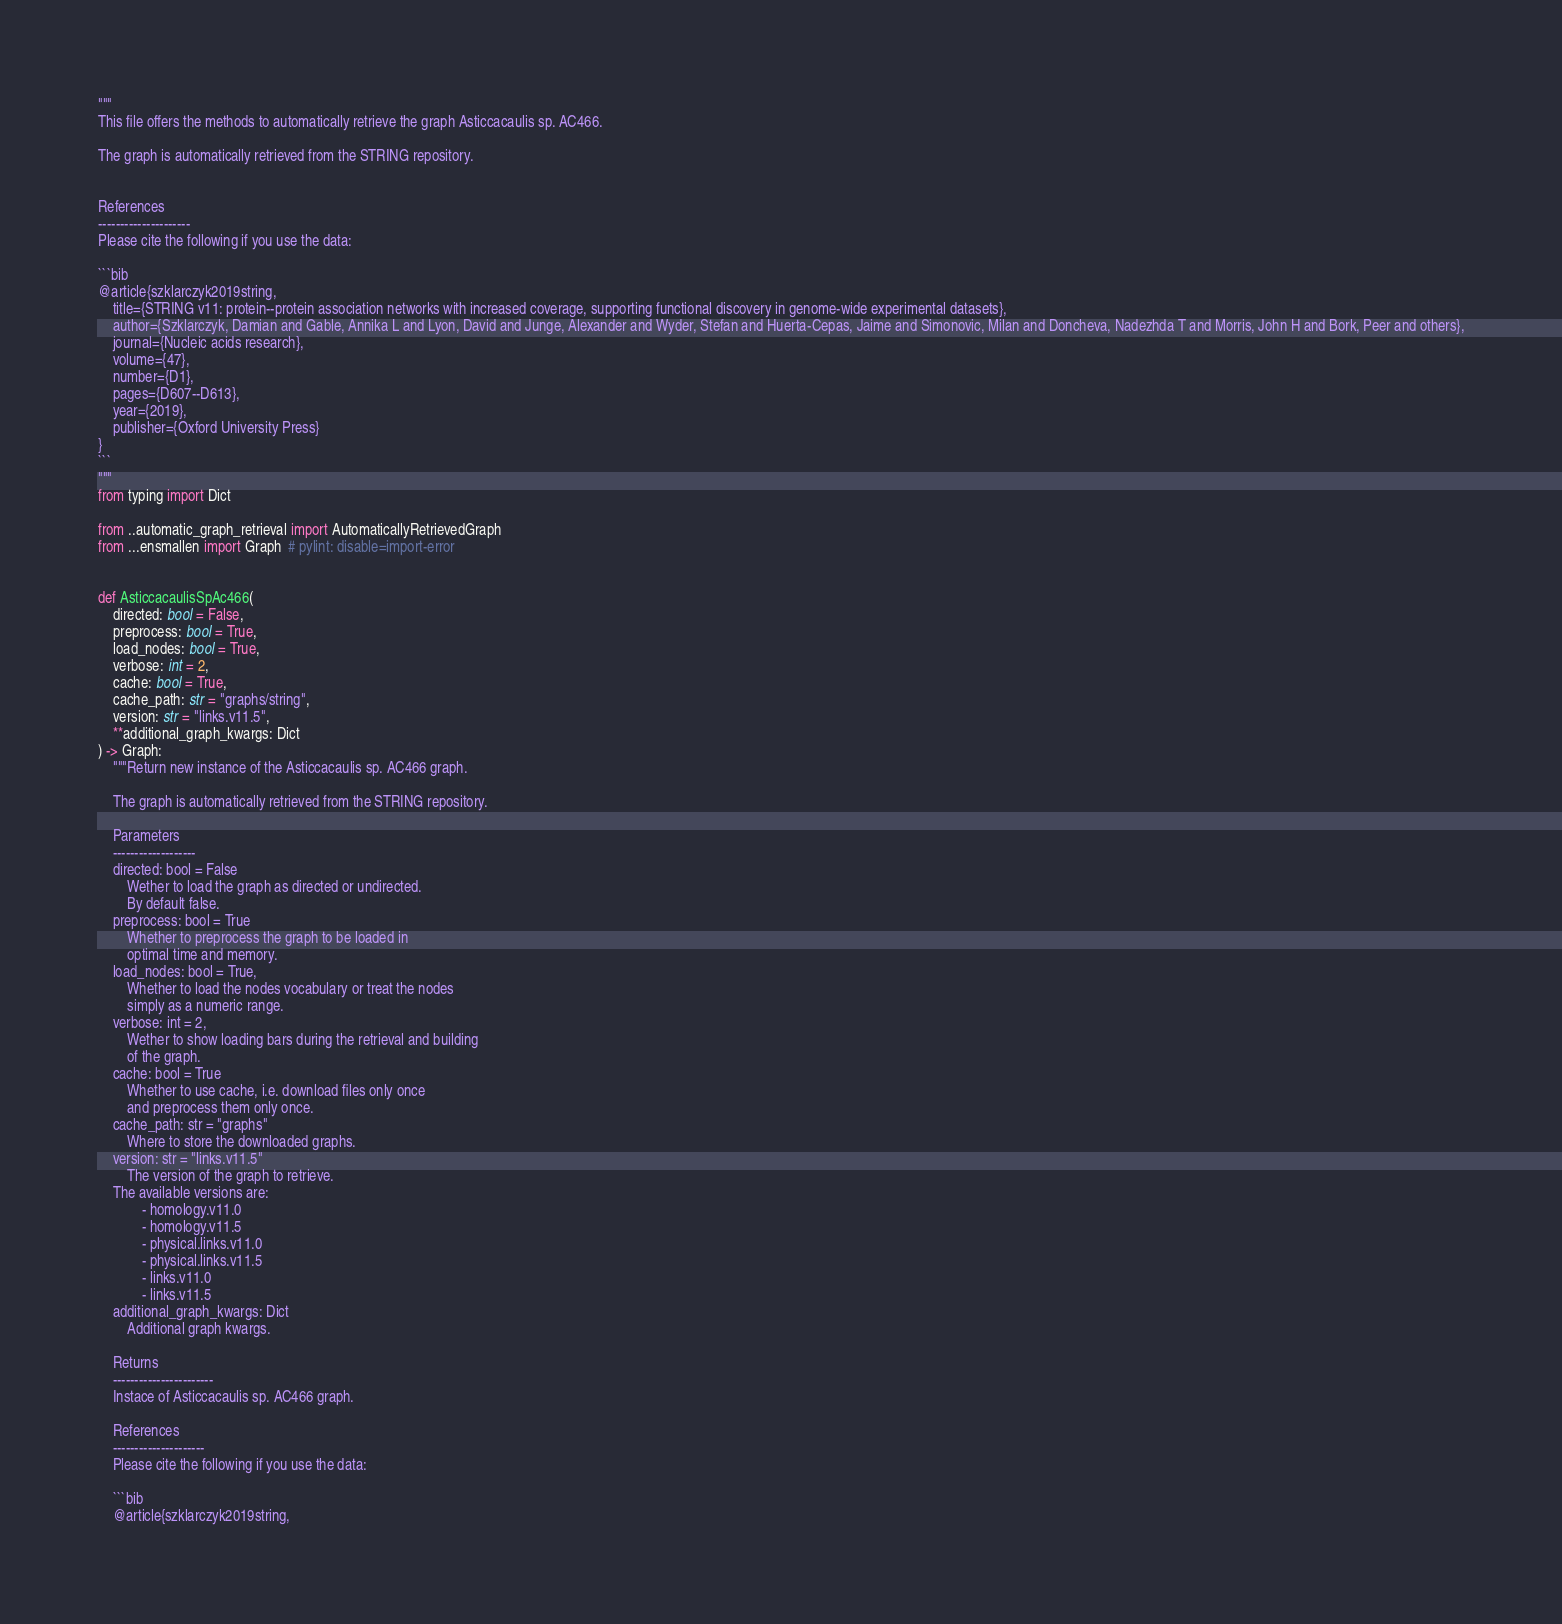Convert code to text. <code><loc_0><loc_0><loc_500><loc_500><_Python_>"""
This file offers the methods to automatically retrieve the graph Asticcacaulis sp. AC466.

The graph is automatically retrieved from the STRING repository. 


References
---------------------
Please cite the following if you use the data:

```bib
@article{szklarczyk2019string,
    title={STRING v11: protein--protein association networks with increased coverage, supporting functional discovery in genome-wide experimental datasets},
    author={Szklarczyk, Damian and Gable, Annika L and Lyon, David and Junge, Alexander and Wyder, Stefan and Huerta-Cepas, Jaime and Simonovic, Milan and Doncheva, Nadezhda T and Morris, John H and Bork, Peer and others},
    journal={Nucleic acids research},
    volume={47},
    number={D1},
    pages={D607--D613},
    year={2019},
    publisher={Oxford University Press}
}
```
"""
from typing import Dict

from ..automatic_graph_retrieval import AutomaticallyRetrievedGraph
from ...ensmallen import Graph  # pylint: disable=import-error


def AsticcacaulisSpAc466(
    directed: bool = False,
    preprocess: bool = True,
    load_nodes: bool = True,
    verbose: int = 2,
    cache: bool = True,
    cache_path: str = "graphs/string",
    version: str = "links.v11.5",
    **additional_graph_kwargs: Dict
) -> Graph:
    """Return new instance of the Asticcacaulis sp. AC466 graph.

    The graph is automatically retrieved from the STRING repository.	

    Parameters
    -------------------
    directed: bool = False
        Wether to load the graph as directed or undirected.
        By default false.
    preprocess: bool = True
        Whether to preprocess the graph to be loaded in 
        optimal time and memory.
    load_nodes: bool = True,
        Whether to load the nodes vocabulary or treat the nodes
        simply as a numeric range.
    verbose: int = 2,
        Wether to show loading bars during the retrieval and building
        of the graph.
    cache: bool = True
        Whether to use cache, i.e. download files only once
        and preprocess them only once.
    cache_path: str = "graphs"
        Where to store the downloaded graphs.
    version: str = "links.v11.5"
        The version of the graph to retrieve.		
	The available versions are:
			- homology.v11.0
			- homology.v11.5
			- physical.links.v11.0
			- physical.links.v11.5
			- links.v11.0
			- links.v11.5
    additional_graph_kwargs: Dict
        Additional graph kwargs.

    Returns
    -----------------------
    Instace of Asticcacaulis sp. AC466 graph.

	References
	---------------------
	Please cite the following if you use the data:
	
	```bib
	@article{szklarczyk2019string,</code> 